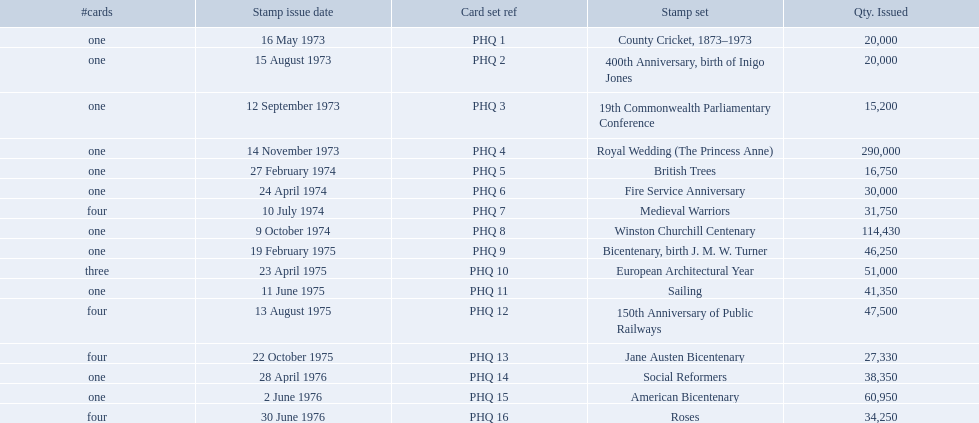What are all the stamp sets? County Cricket, 1873–1973, 400th Anniversary, birth of Inigo Jones, 19th Commonwealth Parliamentary Conference, Royal Wedding (The Princess Anne), British Trees, Fire Service Anniversary, Medieval Warriors, Winston Churchill Centenary, Bicentenary, birth J. M. W. Turner, European Architectural Year, Sailing, 150th Anniversary of Public Railways, Jane Austen Bicentenary, Social Reformers, American Bicentenary, Roses. For these sets, what were the quantities issued? 20,000, 20,000, 15,200, 290,000, 16,750, 30,000, 31,750, 114,430, 46,250, 51,000, 41,350, 47,500, 27,330, 38,350, 60,950, 34,250. Of these, which quantity is above 200,000? 290,000. What is the stamp set corresponding to this quantity? Royal Wedding (The Princess Anne). 